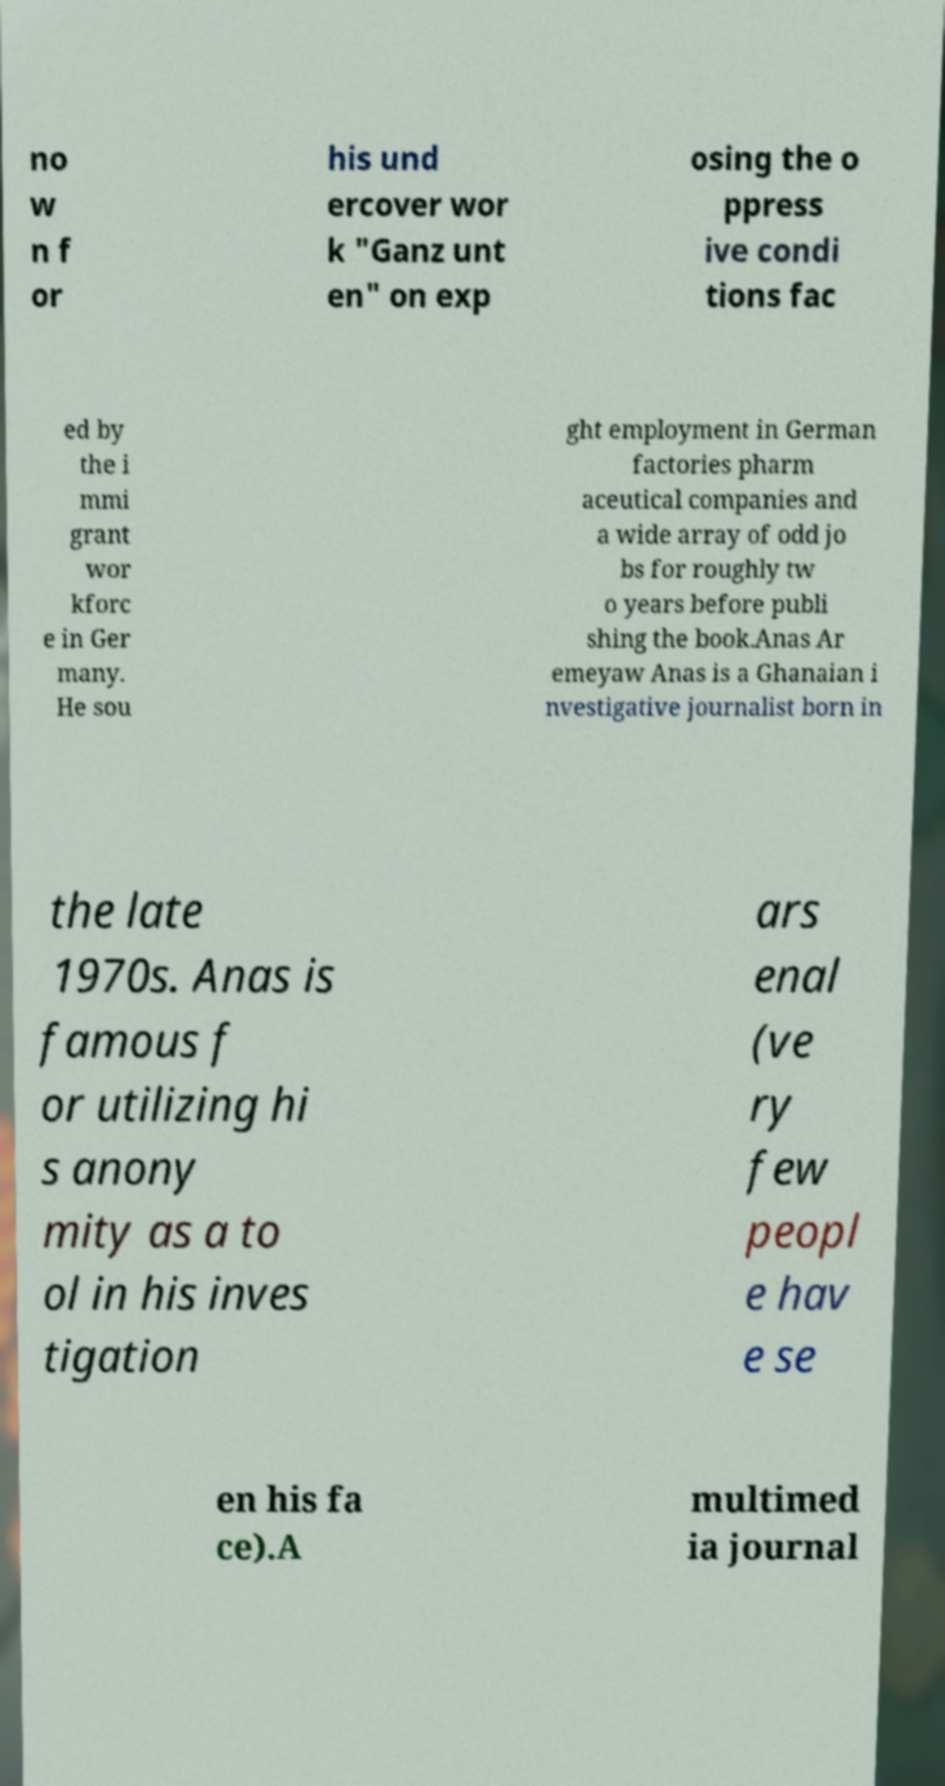There's text embedded in this image that I need extracted. Can you transcribe it verbatim? no w n f or his und ercover wor k "Ganz unt en" on exp osing the o ppress ive condi tions fac ed by the i mmi grant wor kforc e in Ger many. He sou ght employment in German factories pharm aceutical companies and a wide array of odd jo bs for roughly tw o years before publi shing the book.Anas Ar emeyaw Anas is a Ghanaian i nvestigative journalist born in the late 1970s. Anas is famous f or utilizing hi s anony mity as a to ol in his inves tigation ars enal (ve ry few peopl e hav e se en his fa ce).A multimed ia journal 